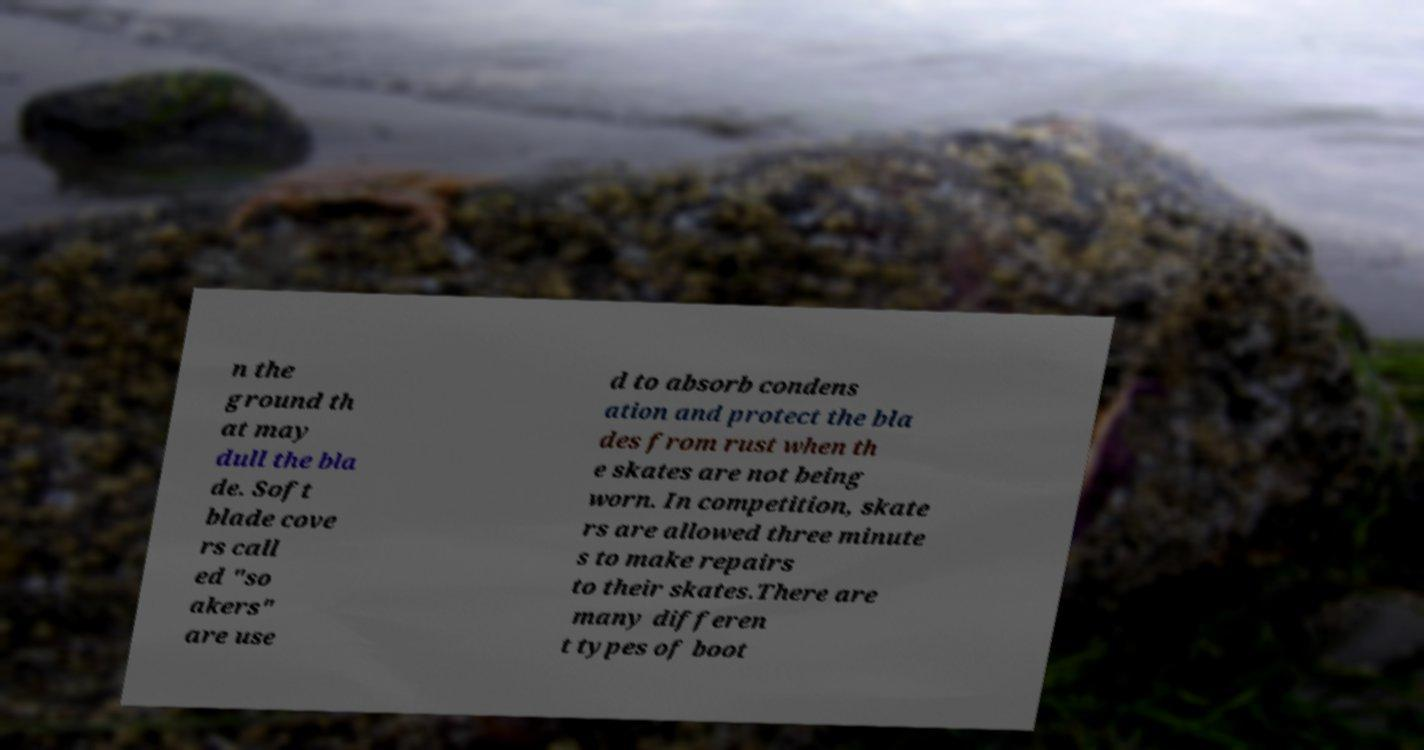What messages or text are displayed in this image? I need them in a readable, typed format. n the ground th at may dull the bla de. Soft blade cove rs call ed "so akers" are use d to absorb condens ation and protect the bla des from rust when th e skates are not being worn. In competition, skate rs are allowed three minute s to make repairs to their skates.There are many differen t types of boot 